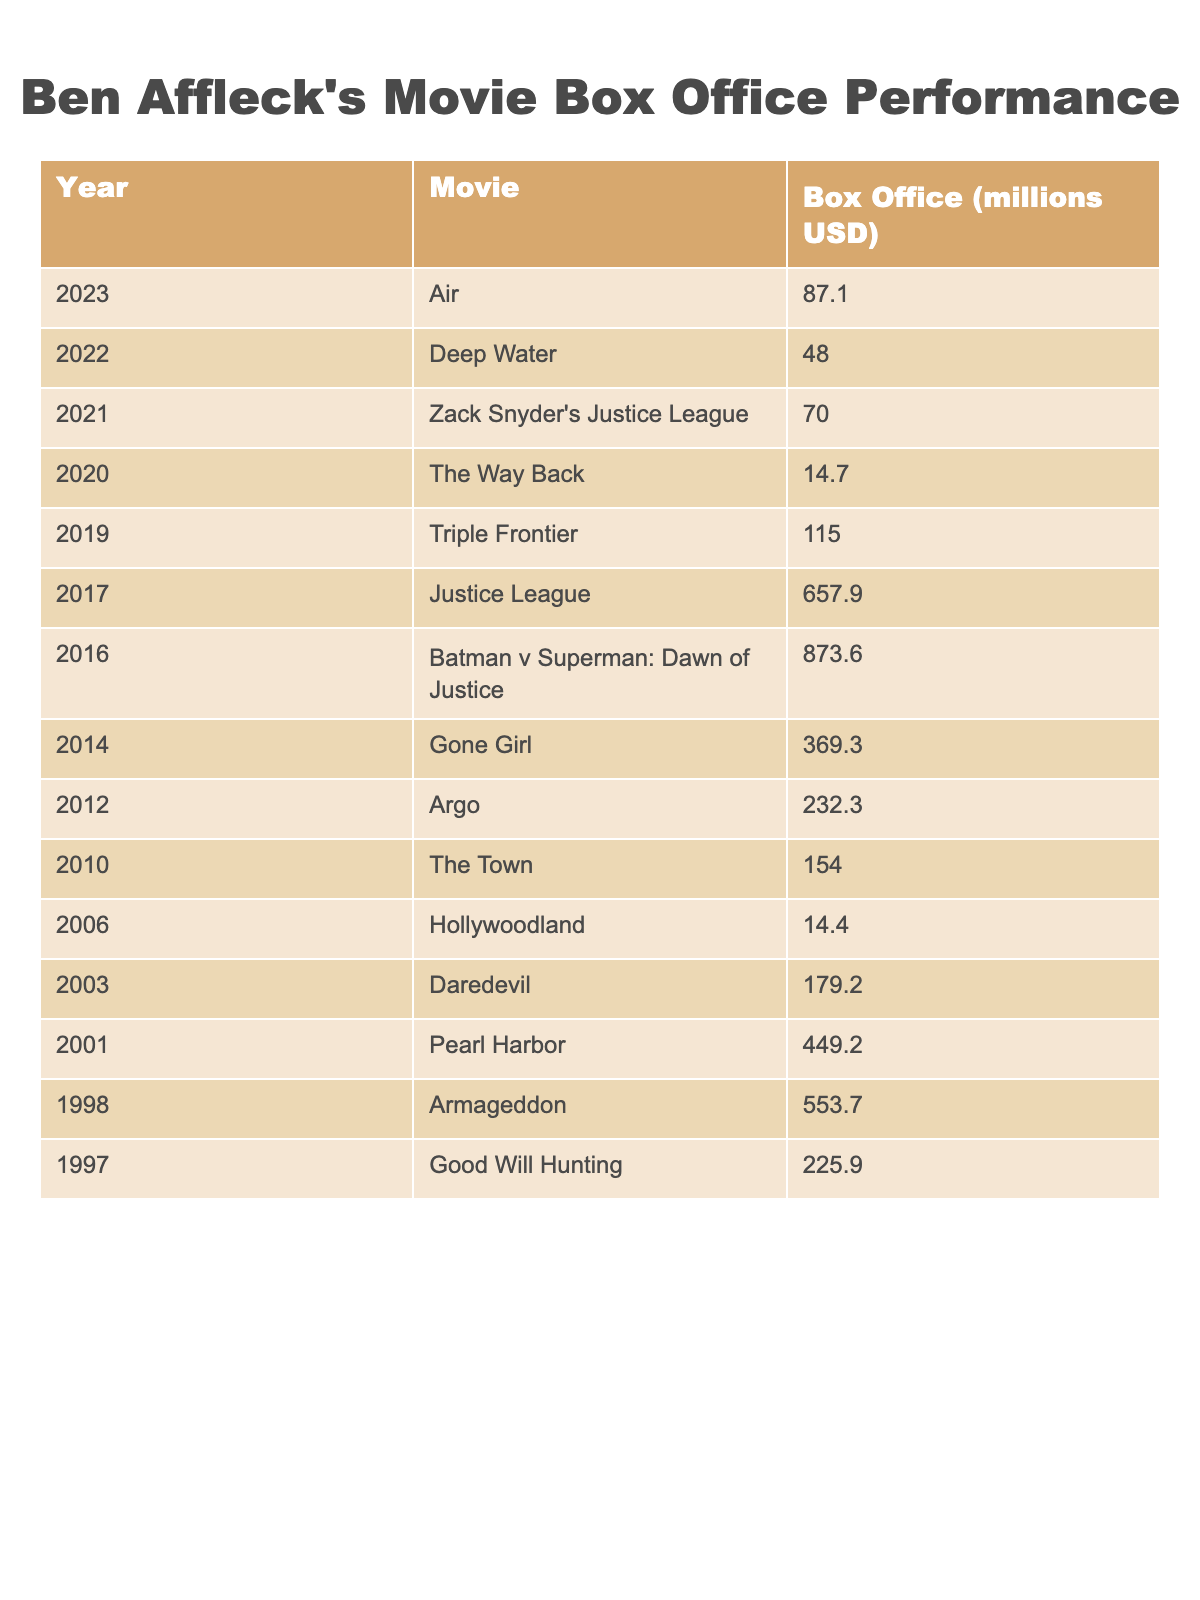What is the highest box office gross for a Ben Affleck movie? The table shows that "Batman v Superman: Dawn of Justice" has the highest box office gross at 873.6 million USD.
Answer: 873.6 million USD In which year did Ben Affleck release the most movies in this table? By reviewing the data, we see that there are two movies listed for 2016 ("Batman v Superman: Dawn of Justice" and "Justice League"), which is more than any other year.
Answer: 2016 What is the total box office gross of Ben Affleck's movies between 2010 and 2022? Adding the box office totals for each movie from 2010 to 2022: (154.0 + 232.3 + 369.3 + 873.6 + 657.9 + 115.0 + 14.7 + 70.0 + 48.0 + 87.1) equals 2,978.0 million USD.
Answer: 2,978.0 million USD Which movie had the lowest box office gross? The table indicates that "Hollywoodland" has the lowest box office gross at 14.4 million USD.
Answer: 14.4 million USD What is the average box office gross of Ben Affleck's movies released after 2010? The movies after 2010 are "The Town," "Argo," "Gone Girl," "Batman v Superman: Dawn of Justice," "Justice League," "Triple Frontier," "The Way Back," "Zack Snyder's Justice League," "Deep Water," and "Air." Adding their grosses (154.0 + 232.3 + 369.3 + 873.6 + 657.9 + 115.0 + 14.7 + 70.0 + 48.0 + 87.1) gives a total of 2,405.0 million USD. There are 10 movies, so the average is 2,405.0/10 = 240.5 million USD.
Answer: 240.5 million USD Was "Good Will Hunting" more successful financially than "Daredevil"? Comparing their box office grosses: "Good Will Hunting" earned 225.9 million USD, while "Daredevil" earned 179.2 million USD. Therefore, "Good Will Hunting" was more successful.
Answer: Yes Which movie was released in 2014 and what was its box office gross? The movie released in 2014 is "Gone Girl," which grossed 369.3 million USD, according to the table.
Answer: "Gone Girl," 369.3 million USD How much more did "Armageddon" earn compared to "The Way Back"? "Armageddon" earned 553.7 million USD and "The Way Back" earned 14.7 million USD. To find the difference, subtract: 553.7 - 14.7 = 539.0 million USD.
Answer: 539.0 million USD How many movies listed had a box office gross of over 500 million USD? The movies with gross over 500 million USD are "Armageddon" (553.7), "Pearl Harbor" (449.2, not included), "Batman v Superman: Dawn of Justice" (873.6), and "Justice League" (657.9), totaling 3 movies.
Answer: 3 movies Which year had the least amount of box office earnings from the movies listed? Checking the box office figures, "Hollywoodland" in 2006 had the lowest gross at 14.4 million USD, making it the least earnings year.
Answer: 2006 